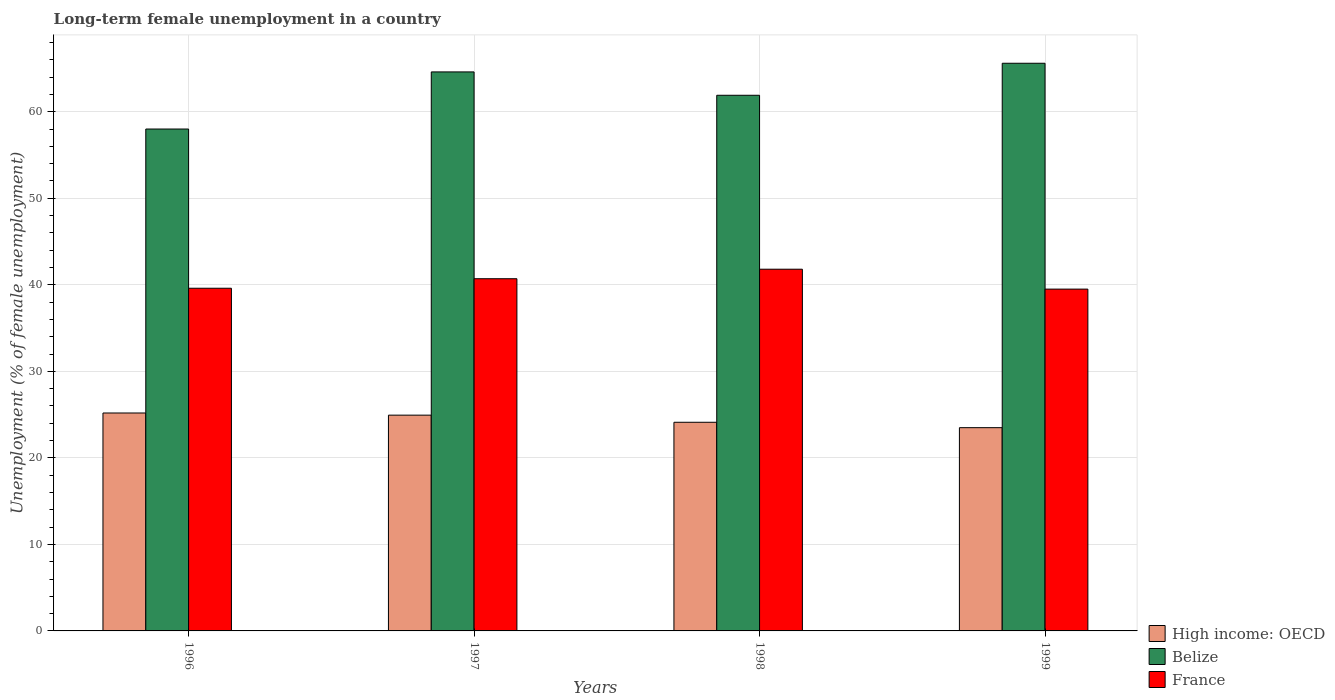How many groups of bars are there?
Offer a terse response. 4. Are the number of bars on each tick of the X-axis equal?
Your answer should be compact. Yes. Across all years, what is the maximum percentage of long-term unemployed female population in Belize?
Your response must be concise. 65.6. Across all years, what is the minimum percentage of long-term unemployed female population in High income: OECD?
Your answer should be very brief. 23.49. What is the total percentage of long-term unemployed female population in France in the graph?
Offer a terse response. 161.6. What is the difference between the percentage of long-term unemployed female population in Belize in 1996 and that in 1997?
Offer a terse response. -6.6. What is the difference between the percentage of long-term unemployed female population in France in 1997 and the percentage of long-term unemployed female population in Belize in 1999?
Give a very brief answer. -24.9. What is the average percentage of long-term unemployed female population in High income: OECD per year?
Your response must be concise. 24.43. In the year 1997, what is the difference between the percentage of long-term unemployed female population in Belize and percentage of long-term unemployed female population in High income: OECD?
Provide a succinct answer. 39.66. In how many years, is the percentage of long-term unemployed female population in High income: OECD greater than 50 %?
Make the answer very short. 0. What is the ratio of the percentage of long-term unemployed female population in High income: OECD in 1996 to that in 1999?
Your answer should be compact. 1.07. What is the difference between the highest and the second highest percentage of long-term unemployed female population in Belize?
Offer a very short reply. 1. What is the difference between the highest and the lowest percentage of long-term unemployed female population in France?
Provide a short and direct response. 2.3. In how many years, is the percentage of long-term unemployed female population in France greater than the average percentage of long-term unemployed female population in France taken over all years?
Provide a short and direct response. 2. What does the 2nd bar from the left in 1997 represents?
Keep it short and to the point. Belize. What does the 1st bar from the right in 1997 represents?
Offer a very short reply. France. Are all the bars in the graph horizontal?
Make the answer very short. No. How many years are there in the graph?
Ensure brevity in your answer.  4. Are the values on the major ticks of Y-axis written in scientific E-notation?
Provide a succinct answer. No. Where does the legend appear in the graph?
Your answer should be very brief. Bottom right. How many legend labels are there?
Your answer should be compact. 3. What is the title of the graph?
Provide a short and direct response. Long-term female unemployment in a country. What is the label or title of the Y-axis?
Ensure brevity in your answer.  Unemployment (% of female unemployment). What is the Unemployment (% of female unemployment) in High income: OECD in 1996?
Offer a very short reply. 25.18. What is the Unemployment (% of female unemployment) in France in 1996?
Your response must be concise. 39.6. What is the Unemployment (% of female unemployment) in High income: OECD in 1997?
Keep it short and to the point. 24.94. What is the Unemployment (% of female unemployment) of Belize in 1997?
Keep it short and to the point. 64.6. What is the Unemployment (% of female unemployment) in France in 1997?
Provide a short and direct response. 40.7. What is the Unemployment (% of female unemployment) in High income: OECD in 1998?
Keep it short and to the point. 24.11. What is the Unemployment (% of female unemployment) in Belize in 1998?
Offer a very short reply. 61.9. What is the Unemployment (% of female unemployment) of France in 1998?
Offer a terse response. 41.8. What is the Unemployment (% of female unemployment) of High income: OECD in 1999?
Give a very brief answer. 23.49. What is the Unemployment (% of female unemployment) of Belize in 1999?
Make the answer very short. 65.6. What is the Unemployment (% of female unemployment) in France in 1999?
Your answer should be very brief. 39.5. Across all years, what is the maximum Unemployment (% of female unemployment) of High income: OECD?
Give a very brief answer. 25.18. Across all years, what is the maximum Unemployment (% of female unemployment) in Belize?
Your answer should be very brief. 65.6. Across all years, what is the maximum Unemployment (% of female unemployment) of France?
Offer a terse response. 41.8. Across all years, what is the minimum Unemployment (% of female unemployment) in High income: OECD?
Provide a short and direct response. 23.49. Across all years, what is the minimum Unemployment (% of female unemployment) of France?
Your response must be concise. 39.5. What is the total Unemployment (% of female unemployment) of High income: OECD in the graph?
Give a very brief answer. 97.72. What is the total Unemployment (% of female unemployment) in Belize in the graph?
Your response must be concise. 250.1. What is the total Unemployment (% of female unemployment) in France in the graph?
Give a very brief answer. 161.6. What is the difference between the Unemployment (% of female unemployment) in High income: OECD in 1996 and that in 1997?
Ensure brevity in your answer.  0.25. What is the difference between the Unemployment (% of female unemployment) of France in 1996 and that in 1997?
Make the answer very short. -1.1. What is the difference between the Unemployment (% of female unemployment) in High income: OECD in 1996 and that in 1998?
Keep it short and to the point. 1.07. What is the difference between the Unemployment (% of female unemployment) in Belize in 1996 and that in 1998?
Offer a very short reply. -3.9. What is the difference between the Unemployment (% of female unemployment) in High income: OECD in 1996 and that in 1999?
Provide a succinct answer. 1.7. What is the difference between the Unemployment (% of female unemployment) of Belize in 1996 and that in 1999?
Keep it short and to the point. -7.6. What is the difference between the Unemployment (% of female unemployment) of France in 1996 and that in 1999?
Ensure brevity in your answer.  0.1. What is the difference between the Unemployment (% of female unemployment) of High income: OECD in 1997 and that in 1998?
Your answer should be very brief. 0.82. What is the difference between the Unemployment (% of female unemployment) of Belize in 1997 and that in 1998?
Offer a terse response. 2.7. What is the difference between the Unemployment (% of female unemployment) of France in 1997 and that in 1998?
Your response must be concise. -1.1. What is the difference between the Unemployment (% of female unemployment) in High income: OECD in 1997 and that in 1999?
Offer a very short reply. 1.45. What is the difference between the Unemployment (% of female unemployment) in France in 1997 and that in 1999?
Your answer should be compact. 1.2. What is the difference between the Unemployment (% of female unemployment) of High income: OECD in 1998 and that in 1999?
Keep it short and to the point. 0.62. What is the difference between the Unemployment (% of female unemployment) in France in 1998 and that in 1999?
Offer a very short reply. 2.3. What is the difference between the Unemployment (% of female unemployment) in High income: OECD in 1996 and the Unemployment (% of female unemployment) in Belize in 1997?
Offer a very short reply. -39.42. What is the difference between the Unemployment (% of female unemployment) in High income: OECD in 1996 and the Unemployment (% of female unemployment) in France in 1997?
Offer a very short reply. -15.52. What is the difference between the Unemployment (% of female unemployment) of High income: OECD in 1996 and the Unemployment (% of female unemployment) of Belize in 1998?
Your answer should be compact. -36.72. What is the difference between the Unemployment (% of female unemployment) in High income: OECD in 1996 and the Unemployment (% of female unemployment) in France in 1998?
Provide a short and direct response. -16.62. What is the difference between the Unemployment (% of female unemployment) of Belize in 1996 and the Unemployment (% of female unemployment) of France in 1998?
Provide a succinct answer. 16.2. What is the difference between the Unemployment (% of female unemployment) of High income: OECD in 1996 and the Unemployment (% of female unemployment) of Belize in 1999?
Make the answer very short. -40.42. What is the difference between the Unemployment (% of female unemployment) in High income: OECD in 1996 and the Unemployment (% of female unemployment) in France in 1999?
Give a very brief answer. -14.32. What is the difference between the Unemployment (% of female unemployment) of Belize in 1996 and the Unemployment (% of female unemployment) of France in 1999?
Ensure brevity in your answer.  18.5. What is the difference between the Unemployment (% of female unemployment) of High income: OECD in 1997 and the Unemployment (% of female unemployment) of Belize in 1998?
Your answer should be very brief. -36.96. What is the difference between the Unemployment (% of female unemployment) in High income: OECD in 1997 and the Unemployment (% of female unemployment) in France in 1998?
Keep it short and to the point. -16.86. What is the difference between the Unemployment (% of female unemployment) of Belize in 1997 and the Unemployment (% of female unemployment) of France in 1998?
Your response must be concise. 22.8. What is the difference between the Unemployment (% of female unemployment) in High income: OECD in 1997 and the Unemployment (% of female unemployment) in Belize in 1999?
Give a very brief answer. -40.66. What is the difference between the Unemployment (% of female unemployment) in High income: OECD in 1997 and the Unemployment (% of female unemployment) in France in 1999?
Offer a very short reply. -14.56. What is the difference between the Unemployment (% of female unemployment) of Belize in 1997 and the Unemployment (% of female unemployment) of France in 1999?
Keep it short and to the point. 25.1. What is the difference between the Unemployment (% of female unemployment) of High income: OECD in 1998 and the Unemployment (% of female unemployment) of Belize in 1999?
Keep it short and to the point. -41.49. What is the difference between the Unemployment (% of female unemployment) in High income: OECD in 1998 and the Unemployment (% of female unemployment) in France in 1999?
Give a very brief answer. -15.39. What is the difference between the Unemployment (% of female unemployment) of Belize in 1998 and the Unemployment (% of female unemployment) of France in 1999?
Offer a very short reply. 22.4. What is the average Unemployment (% of female unemployment) in High income: OECD per year?
Provide a succinct answer. 24.43. What is the average Unemployment (% of female unemployment) in Belize per year?
Keep it short and to the point. 62.52. What is the average Unemployment (% of female unemployment) in France per year?
Ensure brevity in your answer.  40.4. In the year 1996, what is the difference between the Unemployment (% of female unemployment) of High income: OECD and Unemployment (% of female unemployment) of Belize?
Make the answer very short. -32.82. In the year 1996, what is the difference between the Unemployment (% of female unemployment) in High income: OECD and Unemployment (% of female unemployment) in France?
Provide a succinct answer. -14.42. In the year 1997, what is the difference between the Unemployment (% of female unemployment) in High income: OECD and Unemployment (% of female unemployment) in Belize?
Keep it short and to the point. -39.66. In the year 1997, what is the difference between the Unemployment (% of female unemployment) of High income: OECD and Unemployment (% of female unemployment) of France?
Offer a terse response. -15.76. In the year 1997, what is the difference between the Unemployment (% of female unemployment) in Belize and Unemployment (% of female unemployment) in France?
Offer a terse response. 23.9. In the year 1998, what is the difference between the Unemployment (% of female unemployment) of High income: OECD and Unemployment (% of female unemployment) of Belize?
Offer a very short reply. -37.79. In the year 1998, what is the difference between the Unemployment (% of female unemployment) of High income: OECD and Unemployment (% of female unemployment) of France?
Give a very brief answer. -17.69. In the year 1998, what is the difference between the Unemployment (% of female unemployment) in Belize and Unemployment (% of female unemployment) in France?
Your response must be concise. 20.1. In the year 1999, what is the difference between the Unemployment (% of female unemployment) in High income: OECD and Unemployment (% of female unemployment) in Belize?
Provide a short and direct response. -42.11. In the year 1999, what is the difference between the Unemployment (% of female unemployment) in High income: OECD and Unemployment (% of female unemployment) in France?
Give a very brief answer. -16.01. In the year 1999, what is the difference between the Unemployment (% of female unemployment) in Belize and Unemployment (% of female unemployment) in France?
Offer a very short reply. 26.1. What is the ratio of the Unemployment (% of female unemployment) in High income: OECD in 1996 to that in 1997?
Your answer should be very brief. 1.01. What is the ratio of the Unemployment (% of female unemployment) of Belize in 1996 to that in 1997?
Your response must be concise. 0.9. What is the ratio of the Unemployment (% of female unemployment) in France in 1996 to that in 1997?
Your answer should be very brief. 0.97. What is the ratio of the Unemployment (% of female unemployment) of High income: OECD in 1996 to that in 1998?
Your response must be concise. 1.04. What is the ratio of the Unemployment (% of female unemployment) of Belize in 1996 to that in 1998?
Offer a very short reply. 0.94. What is the ratio of the Unemployment (% of female unemployment) of High income: OECD in 1996 to that in 1999?
Give a very brief answer. 1.07. What is the ratio of the Unemployment (% of female unemployment) in Belize in 1996 to that in 1999?
Make the answer very short. 0.88. What is the ratio of the Unemployment (% of female unemployment) in High income: OECD in 1997 to that in 1998?
Make the answer very short. 1.03. What is the ratio of the Unemployment (% of female unemployment) of Belize in 1997 to that in 1998?
Keep it short and to the point. 1.04. What is the ratio of the Unemployment (% of female unemployment) in France in 1997 to that in 1998?
Your answer should be very brief. 0.97. What is the ratio of the Unemployment (% of female unemployment) in High income: OECD in 1997 to that in 1999?
Make the answer very short. 1.06. What is the ratio of the Unemployment (% of female unemployment) of France in 1997 to that in 1999?
Your answer should be very brief. 1.03. What is the ratio of the Unemployment (% of female unemployment) of High income: OECD in 1998 to that in 1999?
Offer a terse response. 1.03. What is the ratio of the Unemployment (% of female unemployment) in Belize in 1998 to that in 1999?
Provide a short and direct response. 0.94. What is the ratio of the Unemployment (% of female unemployment) in France in 1998 to that in 1999?
Offer a terse response. 1.06. What is the difference between the highest and the second highest Unemployment (% of female unemployment) in High income: OECD?
Offer a terse response. 0.25. What is the difference between the highest and the second highest Unemployment (% of female unemployment) in France?
Give a very brief answer. 1.1. What is the difference between the highest and the lowest Unemployment (% of female unemployment) in High income: OECD?
Your response must be concise. 1.7. What is the difference between the highest and the lowest Unemployment (% of female unemployment) of Belize?
Your response must be concise. 7.6. What is the difference between the highest and the lowest Unemployment (% of female unemployment) in France?
Offer a terse response. 2.3. 